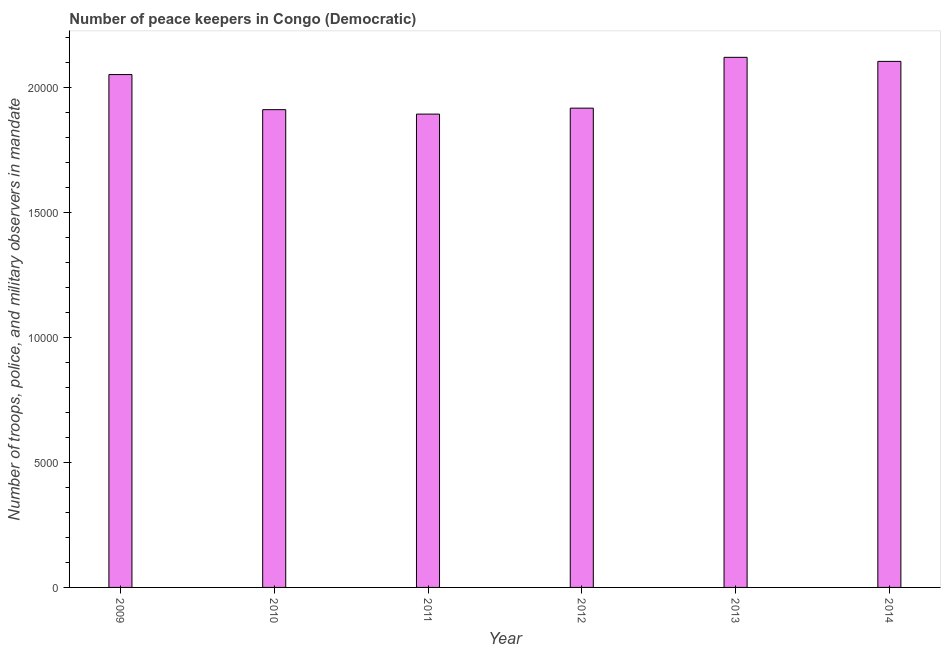Does the graph contain any zero values?
Offer a terse response. No. What is the title of the graph?
Make the answer very short. Number of peace keepers in Congo (Democratic). What is the label or title of the X-axis?
Your answer should be very brief. Year. What is the label or title of the Y-axis?
Provide a succinct answer. Number of troops, police, and military observers in mandate. What is the number of peace keepers in 2013?
Provide a short and direct response. 2.12e+04. Across all years, what is the maximum number of peace keepers?
Offer a very short reply. 2.12e+04. Across all years, what is the minimum number of peace keepers?
Provide a short and direct response. 1.89e+04. What is the sum of the number of peace keepers?
Your answer should be very brief. 1.20e+05. What is the difference between the number of peace keepers in 2011 and 2014?
Offer a terse response. -2108. What is the average number of peace keepers per year?
Your answer should be very brief. 2.00e+04. What is the median number of peace keepers?
Your answer should be compact. 1.98e+04. What is the ratio of the number of peace keepers in 2011 to that in 2013?
Your response must be concise. 0.89. Is the number of peace keepers in 2010 less than that in 2013?
Offer a very short reply. Yes. What is the difference between the highest and the second highest number of peace keepers?
Your response must be concise. 162. What is the difference between the highest and the lowest number of peace keepers?
Provide a succinct answer. 2270. How many bars are there?
Give a very brief answer. 6. How many years are there in the graph?
Your response must be concise. 6. What is the difference between two consecutive major ticks on the Y-axis?
Offer a terse response. 5000. Are the values on the major ticks of Y-axis written in scientific E-notation?
Your answer should be very brief. No. What is the Number of troops, police, and military observers in mandate in 2009?
Your answer should be compact. 2.05e+04. What is the Number of troops, police, and military observers in mandate of 2010?
Offer a terse response. 1.91e+04. What is the Number of troops, police, and military observers in mandate of 2011?
Provide a short and direct response. 1.89e+04. What is the Number of troops, police, and military observers in mandate in 2012?
Make the answer very short. 1.92e+04. What is the Number of troops, police, and military observers in mandate of 2013?
Provide a succinct answer. 2.12e+04. What is the Number of troops, police, and military observers in mandate in 2014?
Offer a very short reply. 2.10e+04. What is the difference between the Number of troops, police, and military observers in mandate in 2009 and 2010?
Your answer should be compact. 1404. What is the difference between the Number of troops, police, and military observers in mandate in 2009 and 2011?
Offer a very short reply. 1581. What is the difference between the Number of troops, police, and military observers in mandate in 2009 and 2012?
Offer a terse response. 1343. What is the difference between the Number of troops, police, and military observers in mandate in 2009 and 2013?
Provide a succinct answer. -689. What is the difference between the Number of troops, police, and military observers in mandate in 2009 and 2014?
Your answer should be very brief. -527. What is the difference between the Number of troops, police, and military observers in mandate in 2010 and 2011?
Your response must be concise. 177. What is the difference between the Number of troops, police, and military observers in mandate in 2010 and 2012?
Ensure brevity in your answer.  -61. What is the difference between the Number of troops, police, and military observers in mandate in 2010 and 2013?
Keep it short and to the point. -2093. What is the difference between the Number of troops, police, and military observers in mandate in 2010 and 2014?
Make the answer very short. -1931. What is the difference between the Number of troops, police, and military observers in mandate in 2011 and 2012?
Give a very brief answer. -238. What is the difference between the Number of troops, police, and military observers in mandate in 2011 and 2013?
Your answer should be very brief. -2270. What is the difference between the Number of troops, police, and military observers in mandate in 2011 and 2014?
Give a very brief answer. -2108. What is the difference between the Number of troops, police, and military observers in mandate in 2012 and 2013?
Provide a short and direct response. -2032. What is the difference between the Number of troops, police, and military observers in mandate in 2012 and 2014?
Provide a short and direct response. -1870. What is the difference between the Number of troops, police, and military observers in mandate in 2013 and 2014?
Your answer should be compact. 162. What is the ratio of the Number of troops, police, and military observers in mandate in 2009 to that in 2010?
Ensure brevity in your answer.  1.07. What is the ratio of the Number of troops, police, and military observers in mandate in 2009 to that in 2011?
Your answer should be very brief. 1.08. What is the ratio of the Number of troops, police, and military observers in mandate in 2009 to that in 2012?
Offer a terse response. 1.07. What is the ratio of the Number of troops, police, and military observers in mandate in 2009 to that in 2013?
Your answer should be compact. 0.97. What is the ratio of the Number of troops, police, and military observers in mandate in 2009 to that in 2014?
Your answer should be compact. 0.97. What is the ratio of the Number of troops, police, and military observers in mandate in 2010 to that in 2011?
Your response must be concise. 1.01. What is the ratio of the Number of troops, police, and military observers in mandate in 2010 to that in 2013?
Your answer should be compact. 0.9. What is the ratio of the Number of troops, police, and military observers in mandate in 2010 to that in 2014?
Your answer should be very brief. 0.91. What is the ratio of the Number of troops, police, and military observers in mandate in 2011 to that in 2012?
Provide a succinct answer. 0.99. What is the ratio of the Number of troops, police, and military observers in mandate in 2011 to that in 2013?
Your response must be concise. 0.89. What is the ratio of the Number of troops, police, and military observers in mandate in 2011 to that in 2014?
Offer a terse response. 0.9. What is the ratio of the Number of troops, police, and military observers in mandate in 2012 to that in 2013?
Provide a short and direct response. 0.9. What is the ratio of the Number of troops, police, and military observers in mandate in 2012 to that in 2014?
Give a very brief answer. 0.91. What is the ratio of the Number of troops, police, and military observers in mandate in 2013 to that in 2014?
Provide a short and direct response. 1.01. 